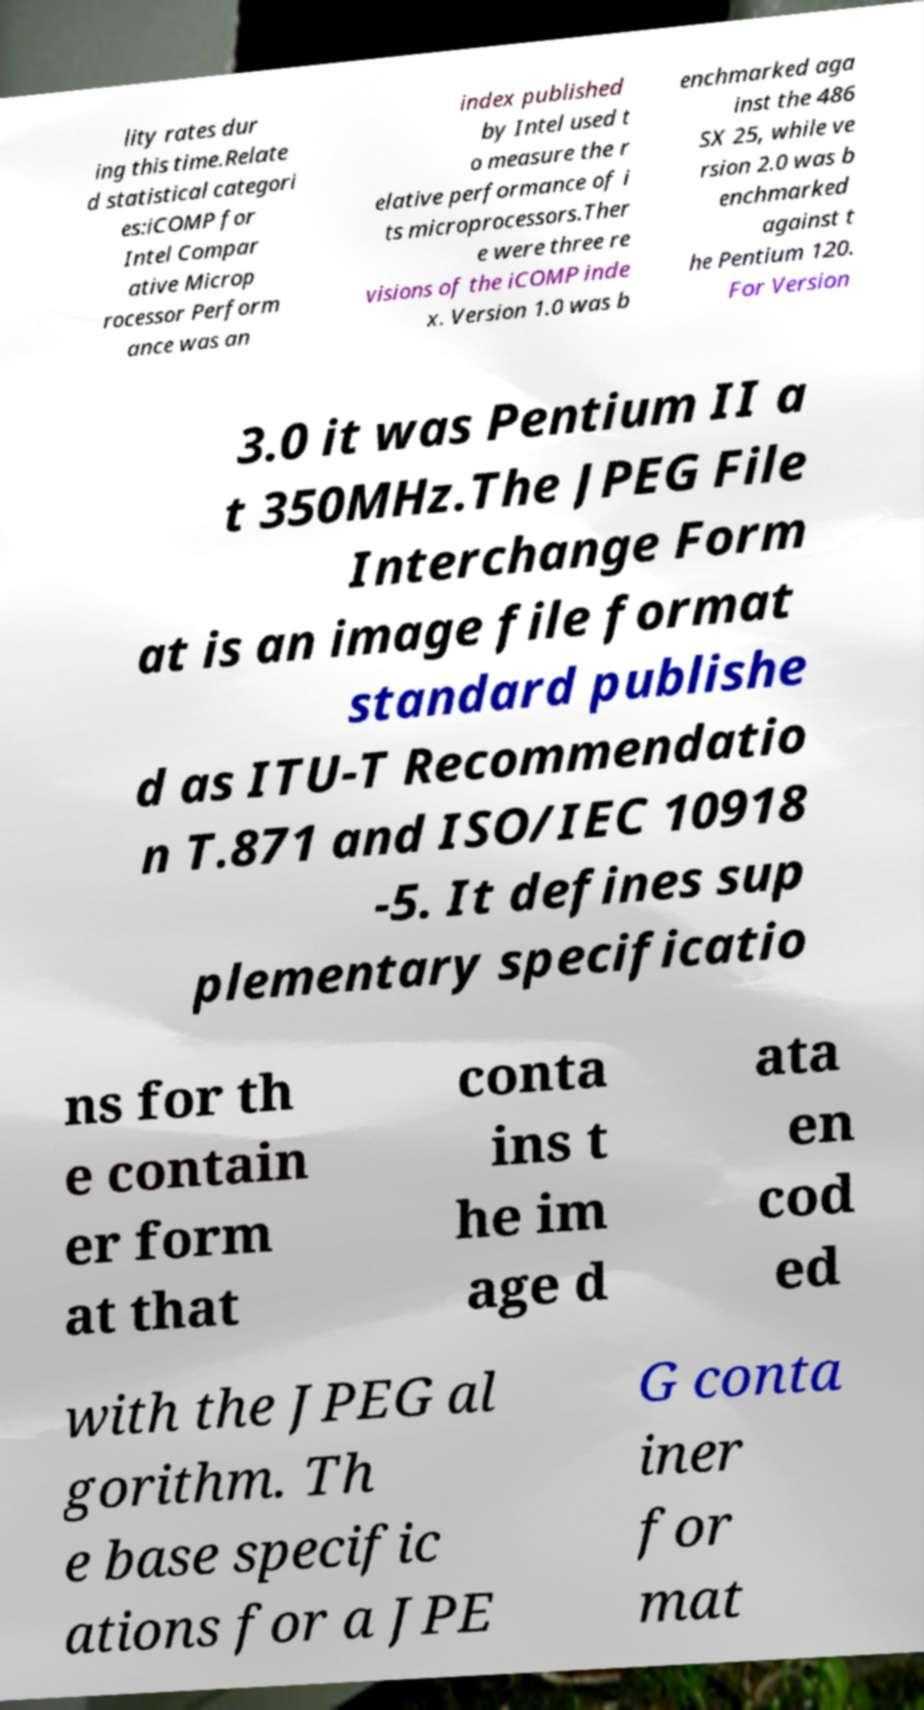Can you accurately transcribe the text from the provided image for me? lity rates dur ing this time.Relate d statistical categori es:iCOMP for Intel Compar ative Microp rocessor Perform ance was an index published by Intel used t o measure the r elative performance of i ts microprocessors.Ther e were three re visions of the iCOMP inde x. Version 1.0 was b enchmarked aga inst the 486 SX 25, while ve rsion 2.0 was b enchmarked against t he Pentium 120. For Version 3.0 it was Pentium II a t 350MHz.The JPEG File Interchange Form at is an image file format standard publishe d as ITU-T Recommendatio n T.871 and ISO/IEC 10918 -5. It defines sup plementary specificatio ns for th e contain er form at that conta ins t he im age d ata en cod ed with the JPEG al gorithm. Th e base specific ations for a JPE G conta iner for mat 